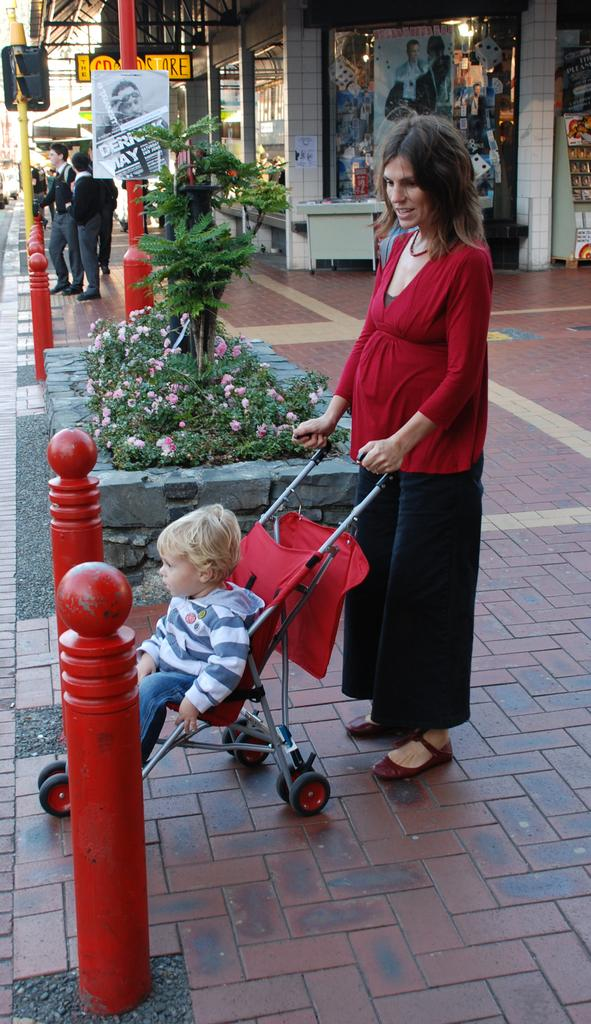What type of structures can be seen in the image? There are buildings in the image. Are there any people present in the image? Yes, there are people standing in the image. Can you describe the woman in the image? The woman is holding a boy in a baby trolley. What else can be seen in the image besides buildings and people? There are poles in the image, and people are standing near the poles. Where is the mailbox located in the image? There is no mailbox present in the image. What type of tail can be seen on the woman holding the boy in the baby trolley? There is no tail present on the woman or the boy in the baby trolley. 